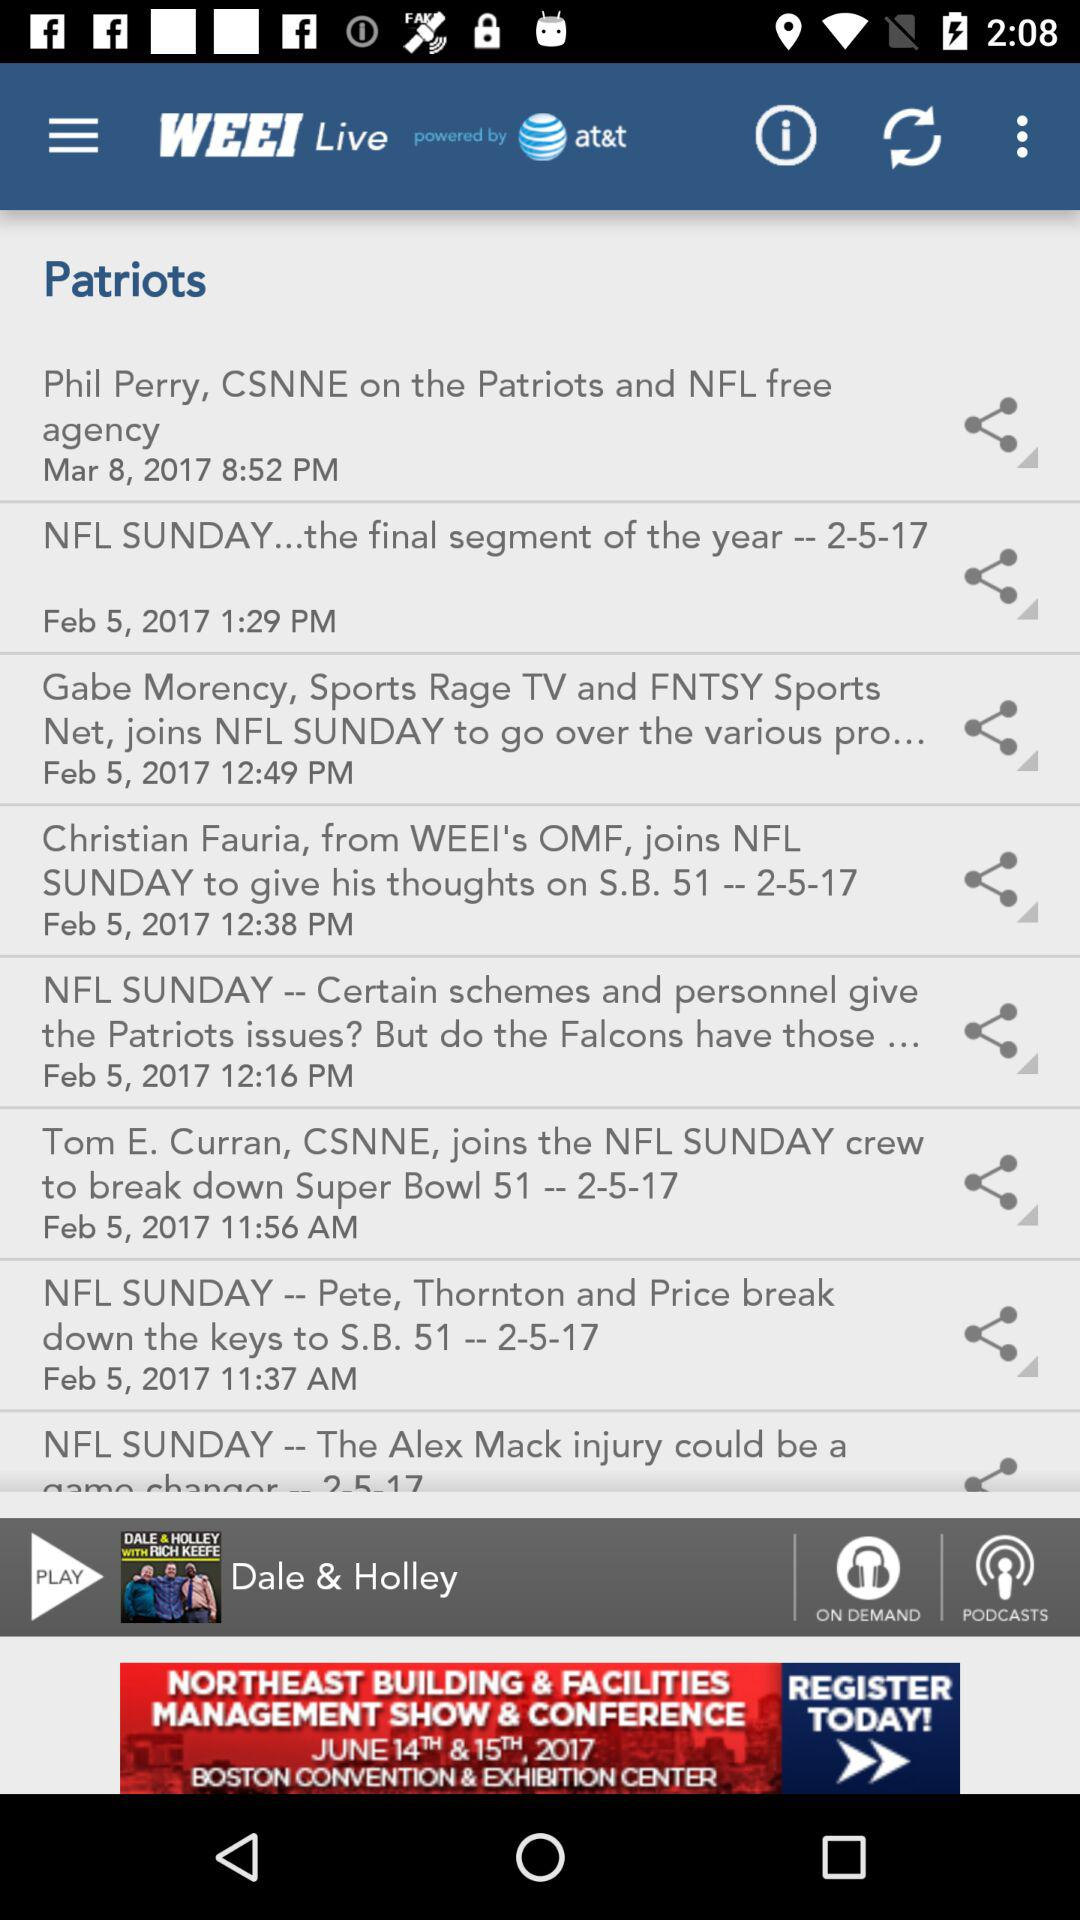What is the application name? The application name is "WEEI". 